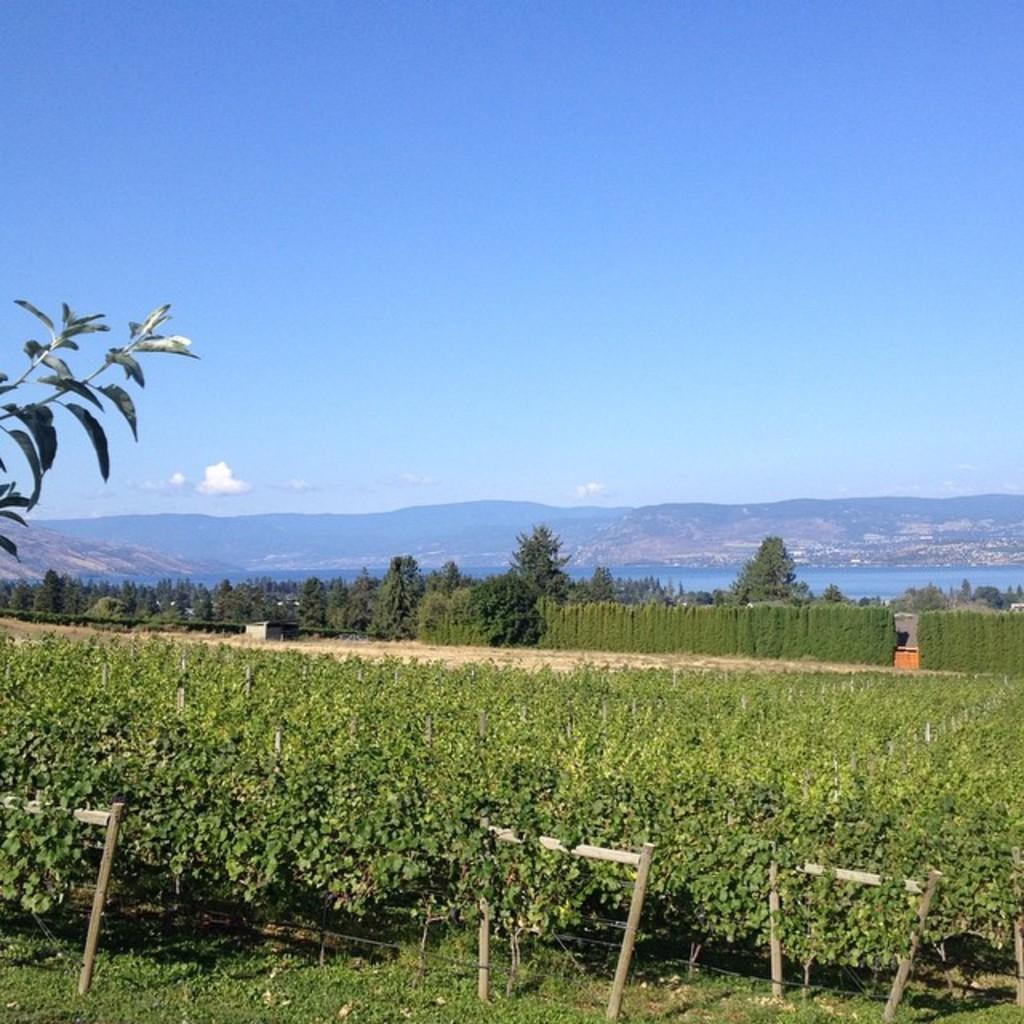Please provide a concise description of this image. There is a field at the bottom of this image, and there are some trees and mountains in the background, and there is a blue sky at the top of this image. 